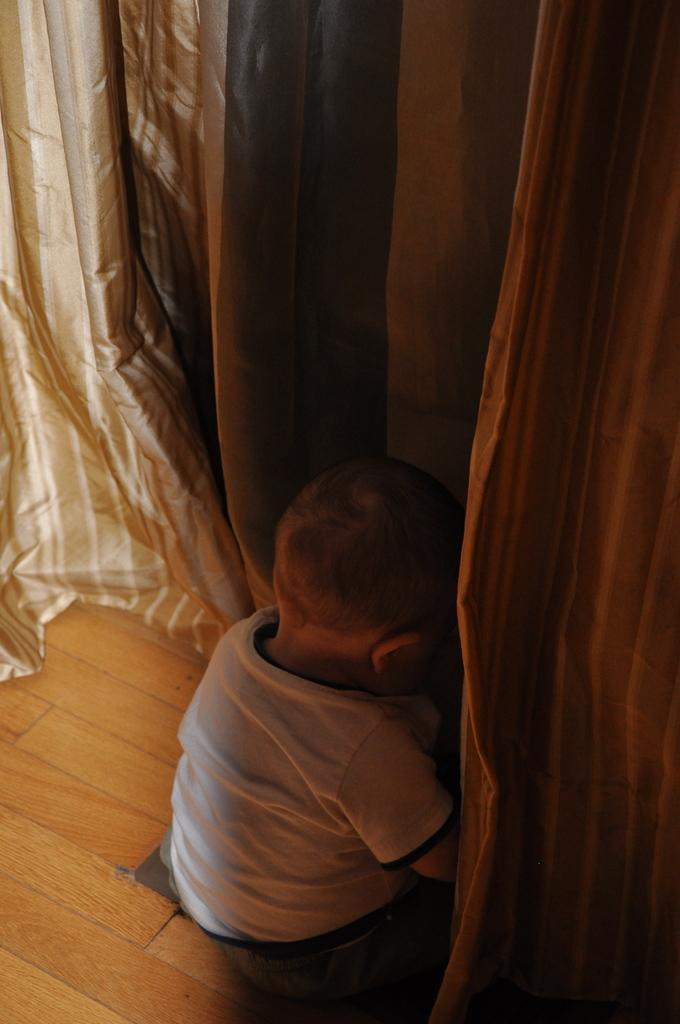Can you describe this image briefly? In this picture there is a small baby in the center of the image and there are curtains at the top side of the image. 